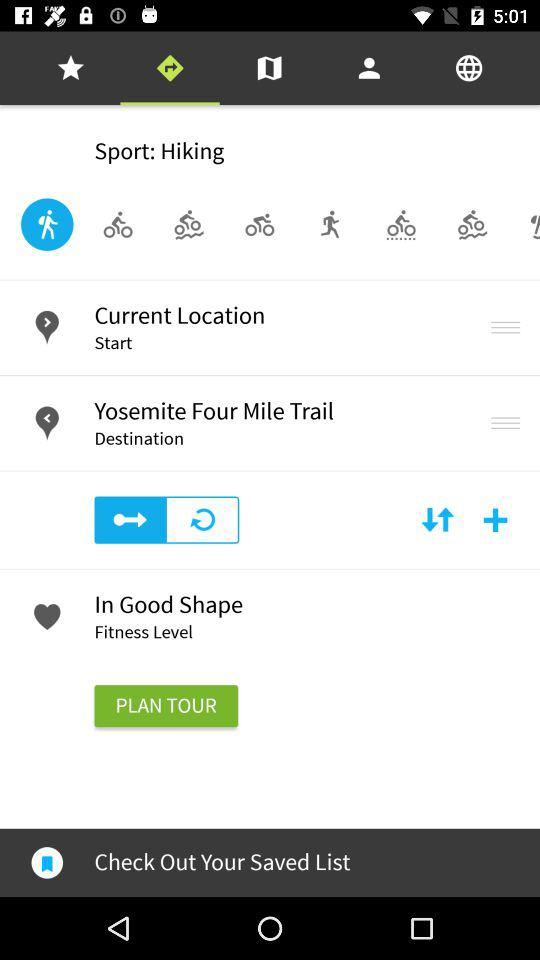What is the name of the sport? The name of the sport is hiking. 